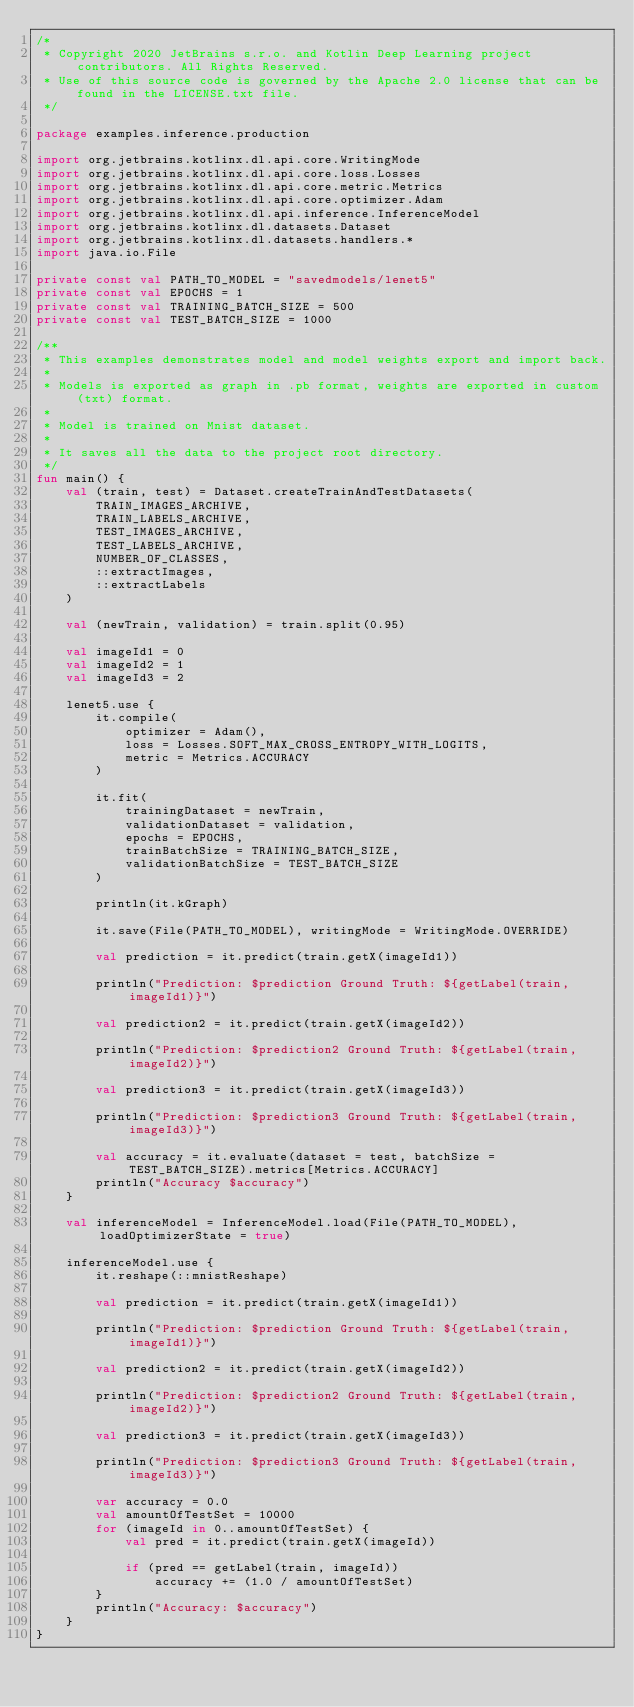<code> <loc_0><loc_0><loc_500><loc_500><_Kotlin_>/*
 * Copyright 2020 JetBrains s.r.o. and Kotlin Deep Learning project contributors. All Rights Reserved.
 * Use of this source code is governed by the Apache 2.0 license that can be found in the LICENSE.txt file.
 */

package examples.inference.production

import org.jetbrains.kotlinx.dl.api.core.WritingMode
import org.jetbrains.kotlinx.dl.api.core.loss.Losses
import org.jetbrains.kotlinx.dl.api.core.metric.Metrics
import org.jetbrains.kotlinx.dl.api.core.optimizer.Adam
import org.jetbrains.kotlinx.dl.api.inference.InferenceModel
import org.jetbrains.kotlinx.dl.datasets.Dataset
import org.jetbrains.kotlinx.dl.datasets.handlers.*
import java.io.File

private const val PATH_TO_MODEL = "savedmodels/lenet5"
private const val EPOCHS = 1
private const val TRAINING_BATCH_SIZE = 500
private const val TEST_BATCH_SIZE = 1000

/**
 * This examples demonstrates model and model weights export and import back.
 *
 * Models is exported as graph in .pb format, weights are exported in custom (txt) format.
 *
 * Model is trained on Mnist dataset.
 *
 * It saves all the data to the project root directory.
 */
fun main() {
    val (train, test) = Dataset.createTrainAndTestDatasets(
        TRAIN_IMAGES_ARCHIVE,
        TRAIN_LABELS_ARCHIVE,
        TEST_IMAGES_ARCHIVE,
        TEST_LABELS_ARCHIVE,
        NUMBER_OF_CLASSES,
        ::extractImages,
        ::extractLabels
    )

    val (newTrain, validation) = train.split(0.95)

    val imageId1 = 0
    val imageId2 = 1
    val imageId3 = 2

    lenet5.use {
        it.compile(
            optimizer = Adam(),
            loss = Losses.SOFT_MAX_CROSS_ENTROPY_WITH_LOGITS,
            metric = Metrics.ACCURACY
        )

        it.fit(
            trainingDataset = newTrain,
            validationDataset = validation,
            epochs = EPOCHS,
            trainBatchSize = TRAINING_BATCH_SIZE,
            validationBatchSize = TEST_BATCH_SIZE
        )

        println(it.kGraph)

        it.save(File(PATH_TO_MODEL), writingMode = WritingMode.OVERRIDE)

        val prediction = it.predict(train.getX(imageId1))

        println("Prediction: $prediction Ground Truth: ${getLabel(train, imageId1)}")

        val prediction2 = it.predict(train.getX(imageId2))

        println("Prediction: $prediction2 Ground Truth: ${getLabel(train, imageId2)}")

        val prediction3 = it.predict(train.getX(imageId3))

        println("Prediction: $prediction3 Ground Truth: ${getLabel(train, imageId3)}")

        val accuracy = it.evaluate(dataset = test, batchSize = TEST_BATCH_SIZE).metrics[Metrics.ACCURACY]
        println("Accuracy $accuracy")
    }

    val inferenceModel = InferenceModel.load(File(PATH_TO_MODEL), loadOptimizerState = true)

    inferenceModel.use {
        it.reshape(::mnistReshape)

        val prediction = it.predict(train.getX(imageId1))

        println("Prediction: $prediction Ground Truth: ${getLabel(train, imageId1)}")

        val prediction2 = it.predict(train.getX(imageId2))

        println("Prediction: $prediction2 Ground Truth: ${getLabel(train, imageId2)}")

        val prediction3 = it.predict(train.getX(imageId3))

        println("Prediction: $prediction3 Ground Truth: ${getLabel(train, imageId3)}")

        var accuracy = 0.0
        val amountOfTestSet = 10000
        for (imageId in 0..amountOfTestSet) {
            val pred = it.predict(train.getX(imageId))

            if (pred == getLabel(train, imageId))
                accuracy += (1.0 / amountOfTestSet)
        }
        println("Accuracy: $accuracy")
    }
}
</code> 